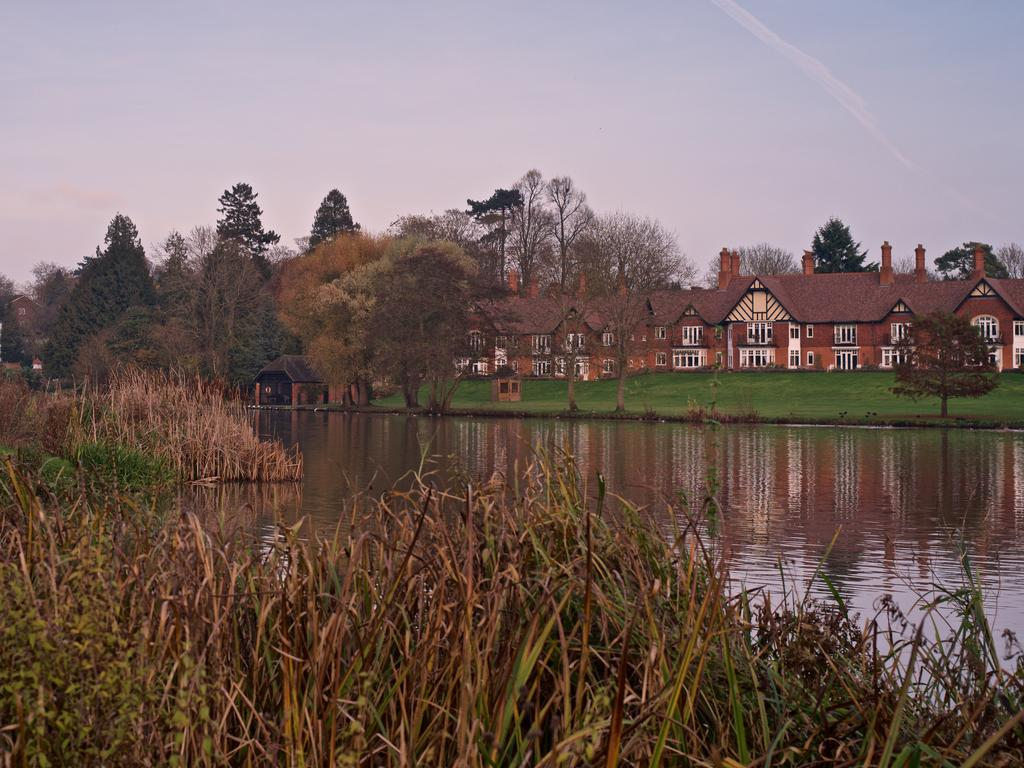What type of living organisms can be seen in the image? Plants and trees are visible in the image. What structures can be seen in the background of the image? There are houses and trees in the background of the image. What is the color of the grass at the bottom of the image? The grass at the bottom of the image is green. What is located in the middle of the image? There is water in the middle of the image. What is visible at the top of the image? The sky is visible at the top of the image. Can you tell me how many flocks of skate are swimming in the water in the image? There are no flocks of skate in the image; it features water in the middle of the scene. How many dimes can be seen on the grass in the image? There are no dimes present on the grass in the image. 